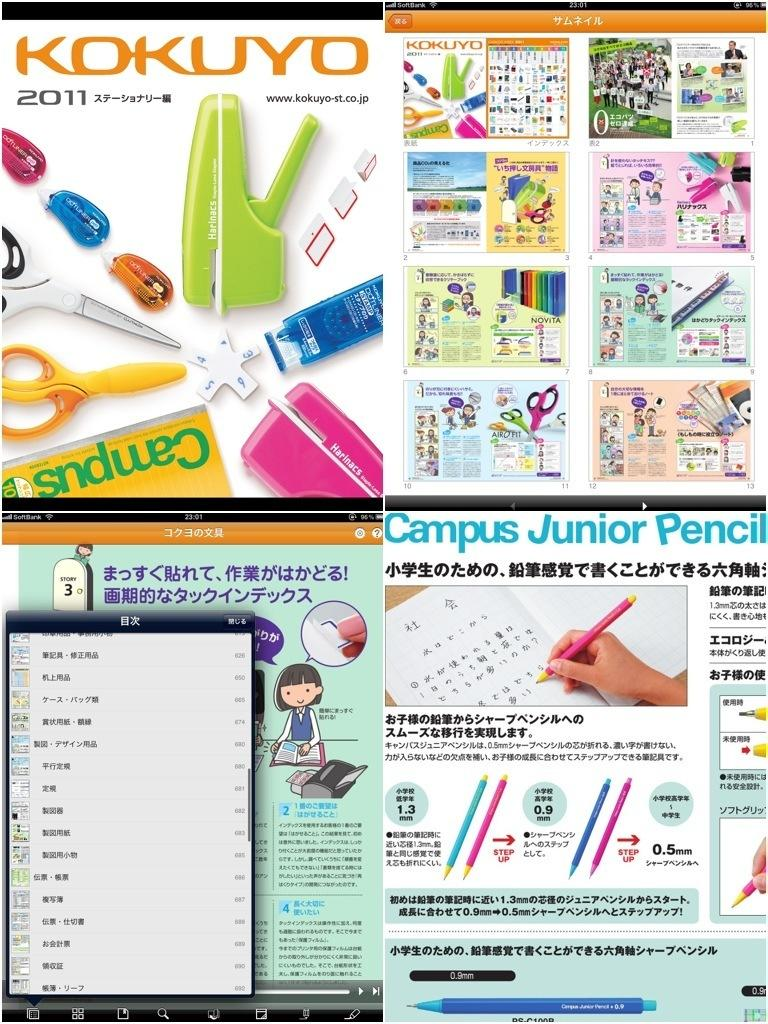<image>
Give a short and clear explanation of the subsequent image. The 2011 catalog for Kokuyo features different office supplies. 